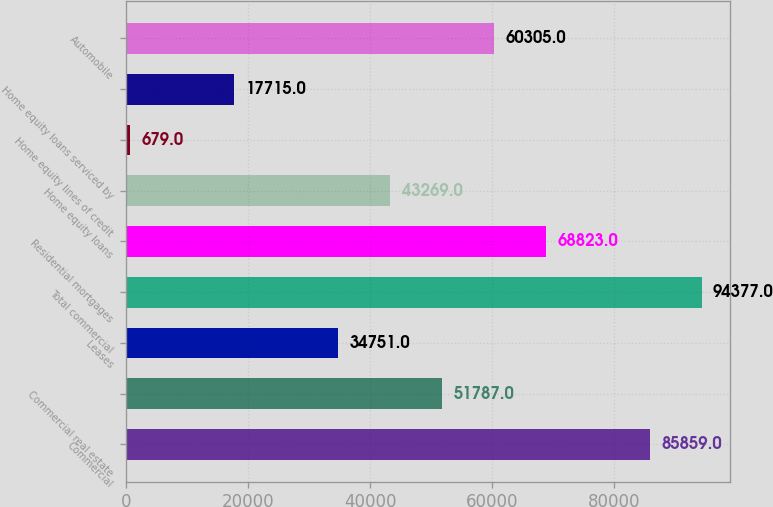Convert chart to OTSL. <chart><loc_0><loc_0><loc_500><loc_500><bar_chart><fcel>Commercial<fcel>Commercial real estate<fcel>Leases<fcel>Total commercial<fcel>Residential mortgages<fcel>Home equity loans<fcel>Home equity lines of credit<fcel>Home equity loans serviced by<fcel>Automobile<nl><fcel>85859<fcel>51787<fcel>34751<fcel>94377<fcel>68823<fcel>43269<fcel>679<fcel>17715<fcel>60305<nl></chart> 